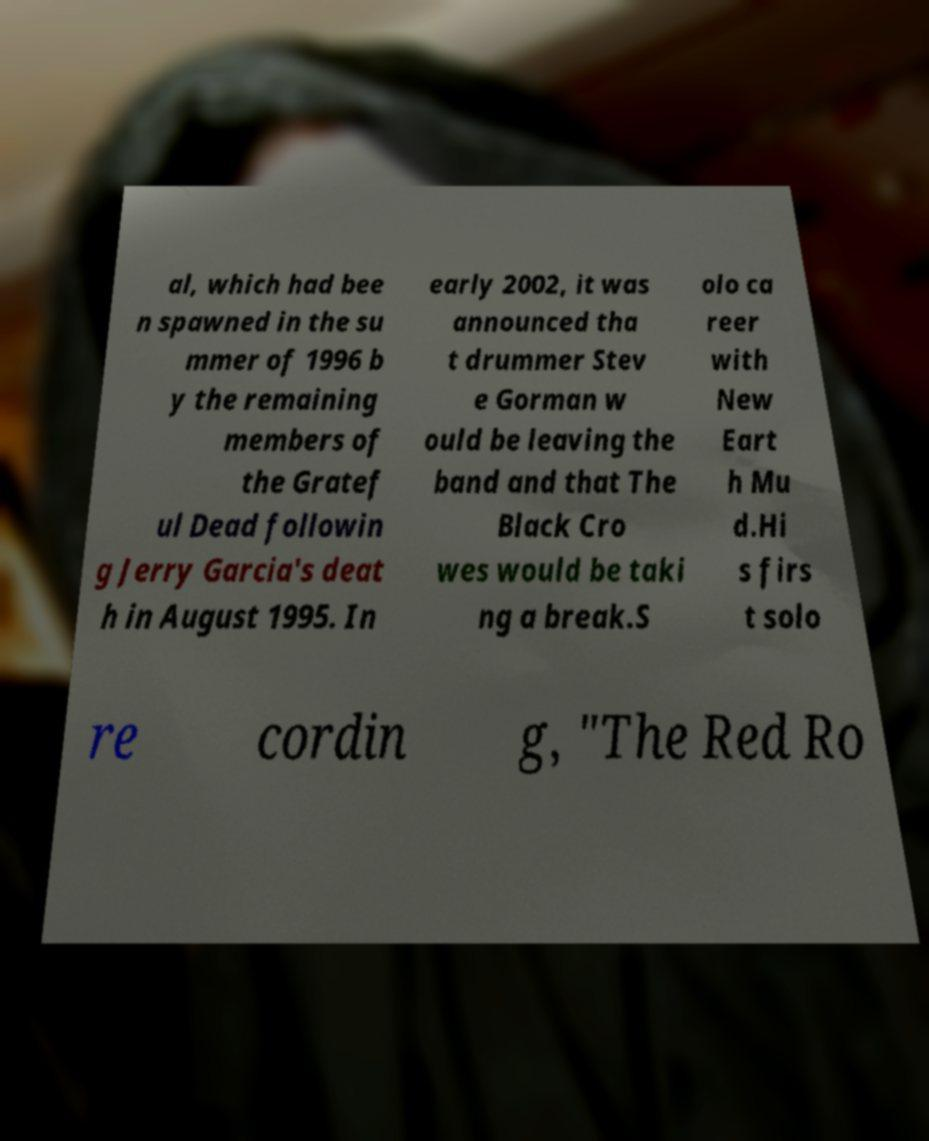Could you extract and type out the text from this image? al, which had bee n spawned in the su mmer of 1996 b y the remaining members of the Gratef ul Dead followin g Jerry Garcia's deat h in August 1995. In early 2002, it was announced tha t drummer Stev e Gorman w ould be leaving the band and that The Black Cro wes would be taki ng a break.S olo ca reer with New Eart h Mu d.Hi s firs t solo re cordin g, "The Red Ro 